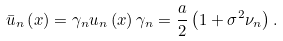<formula> <loc_0><loc_0><loc_500><loc_500>\bar { u } _ { n } \left ( x \right ) = \gamma _ { n } u _ { n } \left ( x \right ) \gamma _ { n } = \frac { a } { 2 } \left ( 1 + \sigma ^ { 2 } \nu _ { n } \right ) .</formula> 